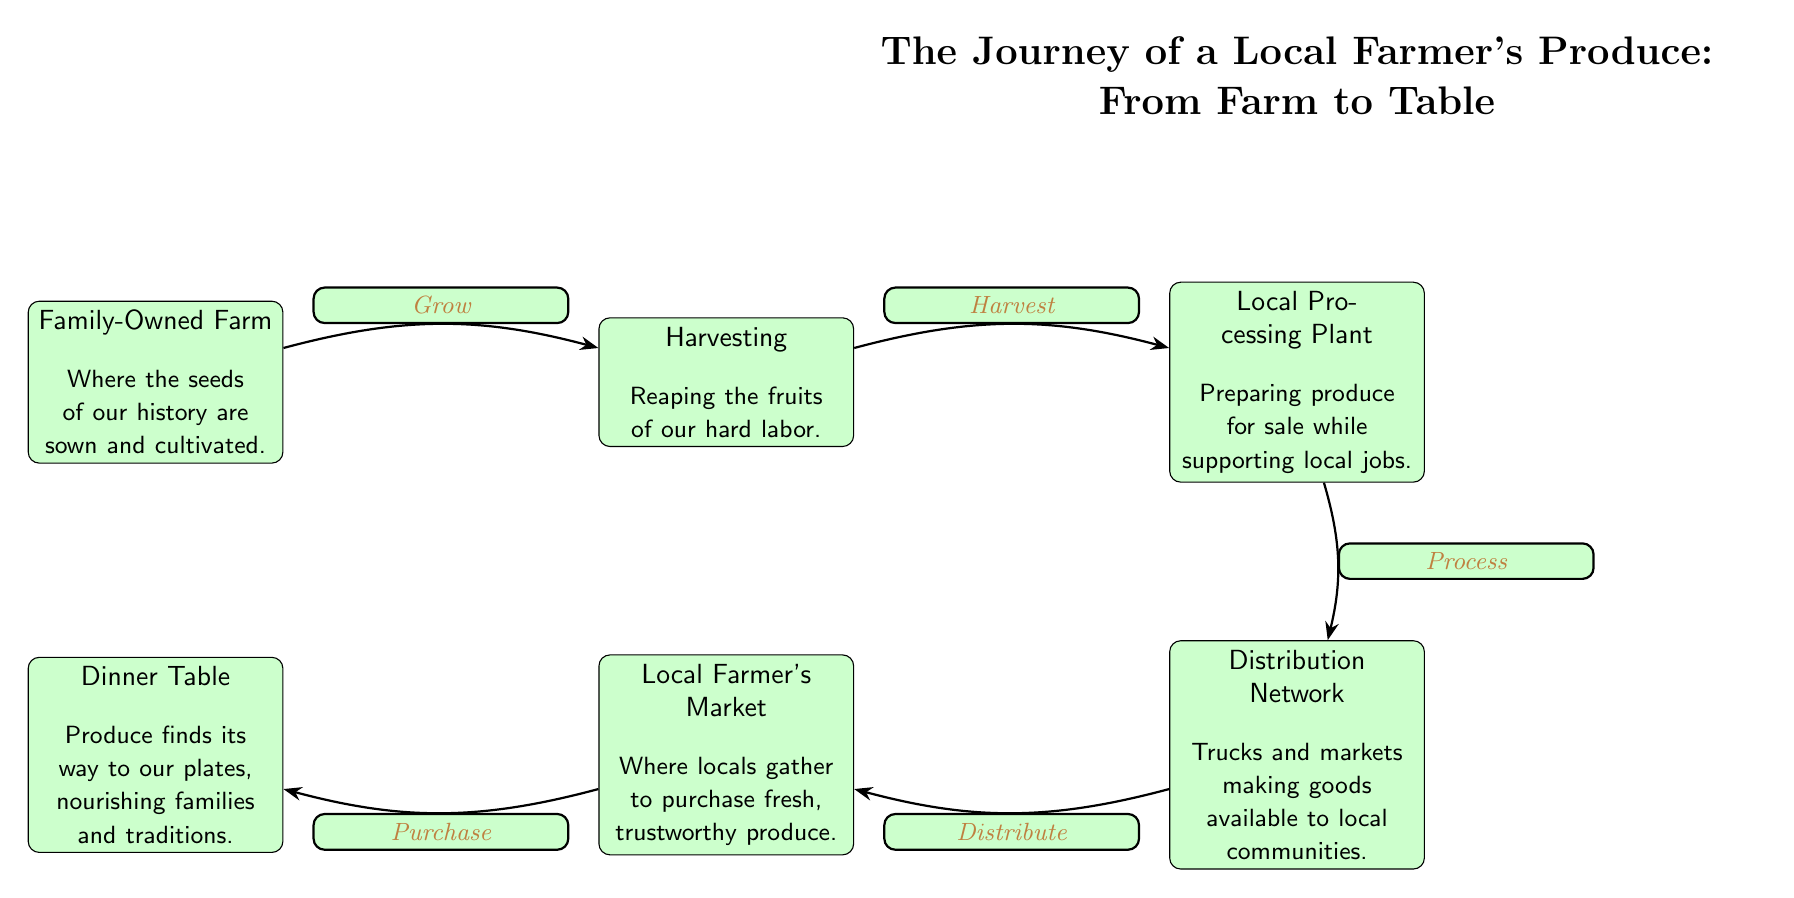What is the first step in the journey of the local farmer's produce? The first step is the Family-Owned Farm, as depicted at the beginning of the flow. This node illustrates where the seeds are sown and cultivated to kickstart the food chain.
Answer: Family-Owned Farm How many nodes are present in this diagram? Counting each unique labeled node reveals there are six in total: Family-Owned Farm, Harvesting, Local Processing Plant, Distribution Network, Local Farmer's Market, and Dinner Table.
Answer: 6 What action occurs between Local Processing Plant and Distribution Network? The diagram indicates the action labeled "Process" that occurs between these two nodes, signifying the preparation of produce for distribution.
Answer: Process Which node represents where the local community purchases produce? The Local Farmer's Market node describes the place where locals gather to purchase fresh produce, as it facilitates the connection between farmers and consumers.
Answer: Local Farmer's Market What is the final destination of the produce in this journey? The last node in the diagram is the Dinner Table, showcasing the final destination where the food is consumed by families, highlighting the completion of the journey.
Answer: Dinner Table What is the relationship between Harvesting and Local Processing Plant? The relationship is defined by the action labeled "Harvest," indicating that after harvesting crops, they are sent to the processing plant for preparation.
Answer: Harvest What do the edges (arrows) in the diagram represent? The edges (arrows) represent the flow of the food chain, indicating the direction and relationship between each step in the journey from farm to table.
Answer: Flow of the food chain What is one benefit highlighted at the Local Processing Plant? The Local Processing Plant emphasizes supporting local jobs as it prepares produce for sale, showing a connection between local economy and agriculture.
Answer: Supporting local jobs What is the significance of the Dinner Table in the food chain? The Dinner Table signifies the culmination of the journey, representing nourishment and the essence of family traditions that are upheld through local produce.
Answer: Nourishing families and traditions 